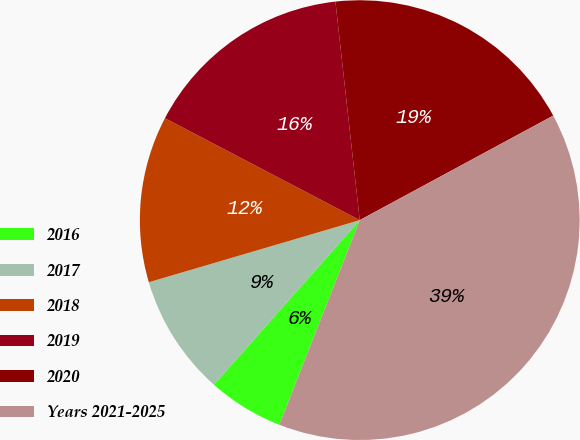Convert chart. <chart><loc_0><loc_0><loc_500><loc_500><pie_chart><fcel>2016<fcel>2017<fcel>2018<fcel>2019<fcel>2020<fcel>Years 2021-2025<nl><fcel>5.58%<fcel>8.9%<fcel>12.23%<fcel>15.56%<fcel>18.88%<fcel>38.84%<nl></chart> 